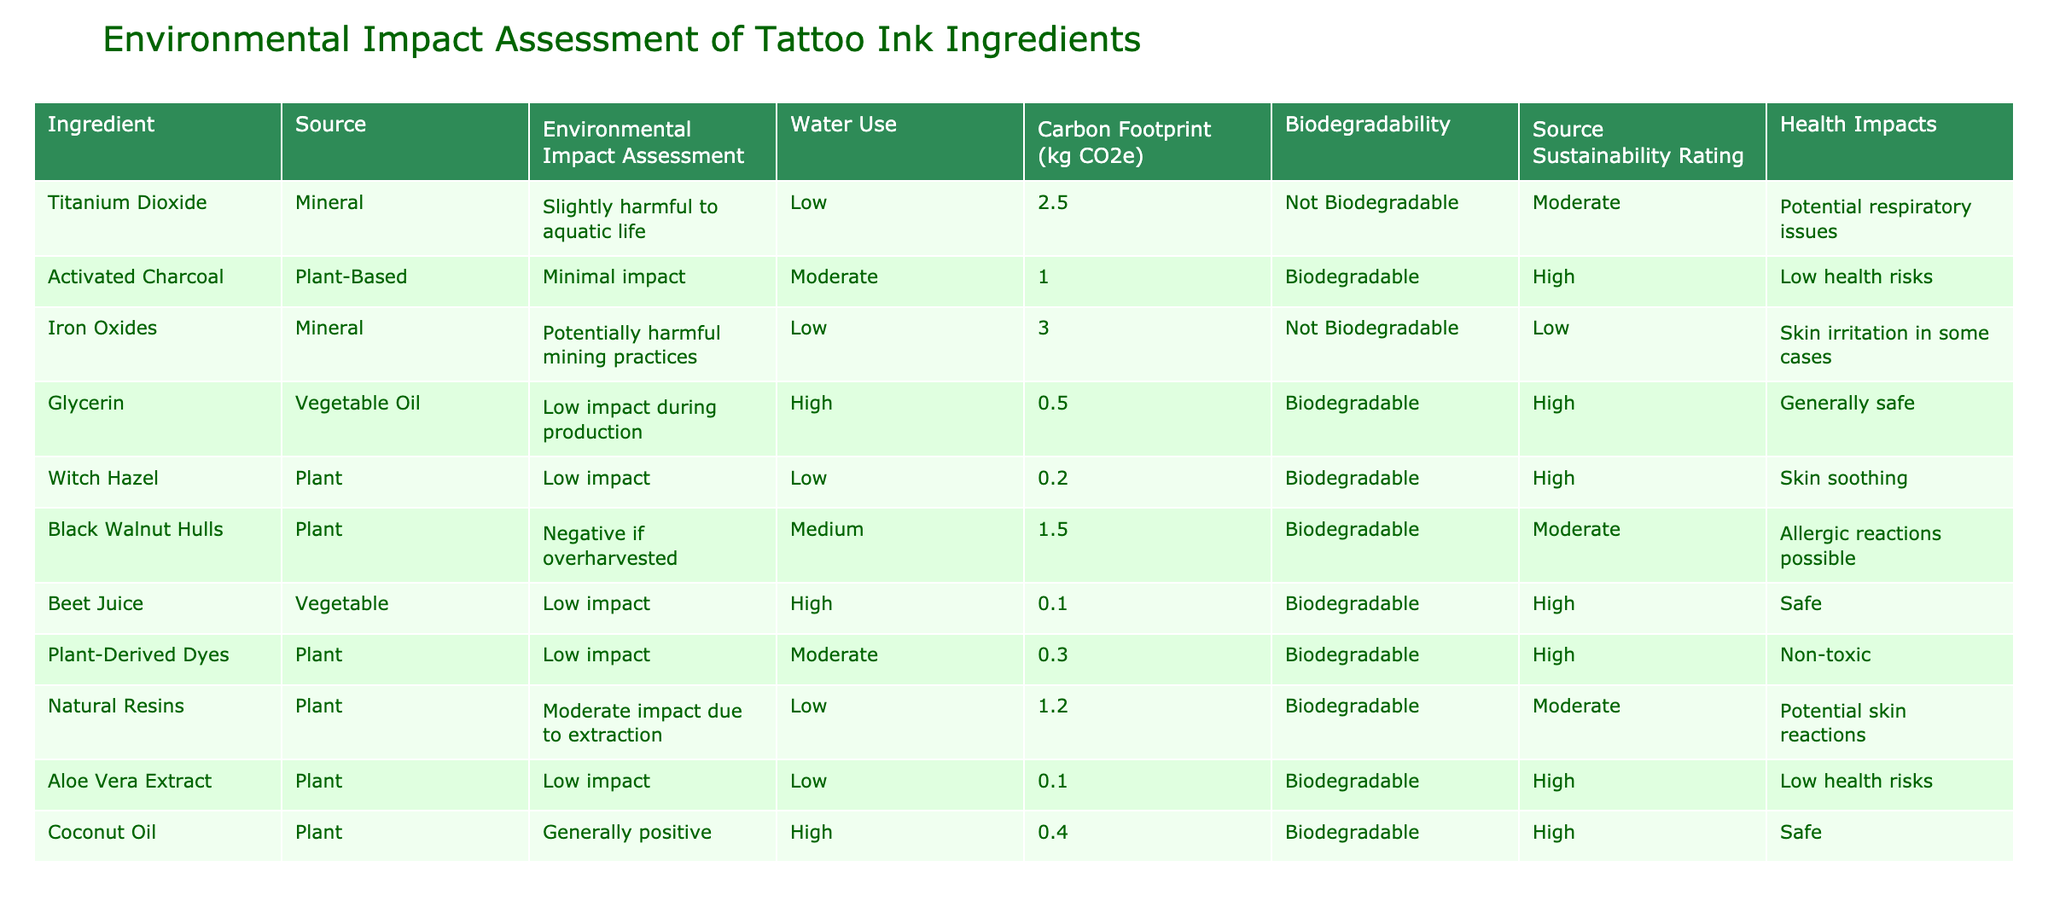What is the carbon footprint of Activated Charcoal? The carbon footprint for Activated Charcoal is listed in the table, which shows it as 1.0 kg CO2e.
Answer: 1.0 kg CO2e Which ingredient has the highest water use? By examining the water use column, Glycerin has the highest water use marked as "High."
Answer: Glycerin Is Titanium Dioxide biodegradable? The table indicates that Titanium Dioxide is "Not Biodegradable."
Answer: No How many ingredients have a "High" source sustainability rating? From the source sustainability ratings, there are four ingredients (Activated Charcoal, Glycerin, Aloe Vera Extract, Coconut Oil) rated as "High."
Answer: 4 Which ingredient poses potential respiratory issues? The health impacts list shows that Titanium Dioxide has potential respiratory issues associated with it.
Answer: Titanium Dioxide What is the average carbon footprint of biodegradable ingredients? The carbon footprints of biodegradable ingredients are 1.0 (Activated Charcoal), 0.5 (Glycerin), 1.5 (Black Walnut Hulls), 0.1 (Beet Juice), 0.3 (Plant-Derived Dyes), 1.2 (Natural Resins), and 0.1 (Aloe Vera Extract), totaling 4.7 for 7 ingredients, giving an average of 4.7/7 = 0.671.
Answer: 0.671 kg CO2e Does Black Walnut Hulls have a high source sustainability rating? The source sustainability rating for Black Walnut Hulls is "Moderate," which means it does not qualify as high.
Answer: No Which ingredient has the lowest environmental impact assessment? By checking the Environmental Impact Assessment column, Activated Charcoal has "Minimal impact," making it the least harmful.
Answer: Activated Charcoal What impacts does Iron Oxides have during mining? The table specifies that Iron Oxides can lead to "Potentially harmful mining practices."
Answer: Potentially harmful mining practices How many ingredients have health impacts categorized as "Low health risks"? The health impact column lists Glycerin, Aloe Vera Extract, and Activated Charcoal under "Low health risks," totaling three ingredients.
Answer: 3 What is the environmental impact of Coconut Oil? The table states Coconut Oil has a "Generally positive" impact concerning environmental assessment.
Answer: Generally positive 